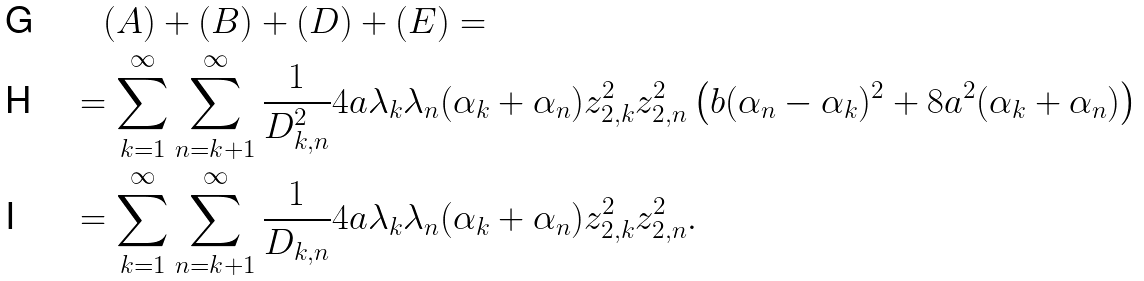<formula> <loc_0><loc_0><loc_500><loc_500>& \quad ( A ) + ( B ) + ( D ) + ( E ) = \\ & = \sum _ { k = 1 } ^ { \infty } \sum _ { n = k + 1 } ^ { \infty } \frac { 1 } { D _ { k , n } ^ { 2 } } 4 a \lambda _ { k } \lambda _ { n } ( \alpha _ { k } + \alpha _ { n } ) z _ { 2 , k } ^ { 2 } z _ { 2 , n } ^ { 2 } \left ( b ( \alpha _ { n } - \alpha _ { k } ) ^ { 2 } + 8 a ^ { 2 } ( \alpha _ { k } + \alpha _ { n } ) \right ) \\ & = \sum _ { k = 1 } ^ { \infty } \sum _ { n = k + 1 } ^ { \infty } \frac { 1 } { D _ { k , n } } 4 a \lambda _ { k } \lambda _ { n } ( \alpha _ { k } + \alpha _ { n } ) z _ { 2 , k } ^ { 2 } z _ { 2 , n } ^ { 2 } .</formula> 